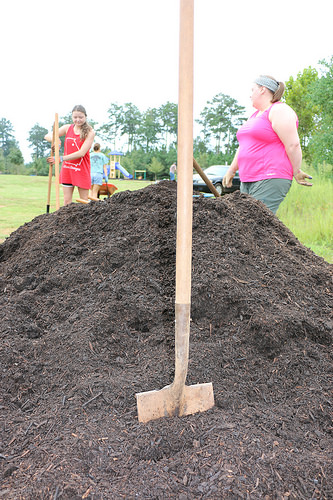<image>
Is the sky behind the tree? Yes. From this viewpoint, the sky is positioned behind the tree, with the tree partially or fully occluding the sky. Is there a sky behind the waste? No. The sky is not behind the waste. From this viewpoint, the sky appears to be positioned elsewhere in the scene. Is there a shovel in front of the woman? Yes. The shovel is positioned in front of the woman, appearing closer to the camera viewpoint. Where is the woman in relation to the shovel? Is it in front of the shovel? No. The woman is not in front of the shovel. The spatial positioning shows a different relationship between these objects. 